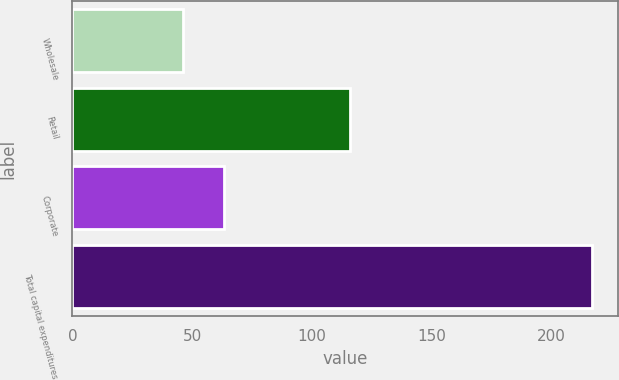<chart> <loc_0><loc_0><loc_500><loc_500><bar_chart><fcel>Wholesale<fcel>Retail<fcel>Corporate<fcel>Total capital expenditures<nl><fcel>46<fcel>116.1<fcel>63.11<fcel>217.1<nl></chart> 